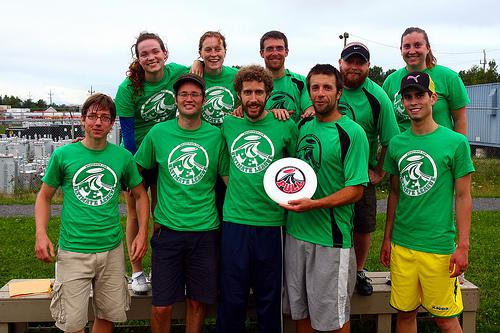Question: what is the main color of the frisbee?
Choices:
A. Red.
B. Blue.
C. Green.
D. White.
Answer with the letter. Answer: D Question: how many people are wearing hats?
Choices:
A. Two.
B. One.
C. Three.
D. Four.
Answer with the letter. Answer: C Question: who is this a picture of?
Choices:
A. Sports team.
B. Friends.
C. Frisbee team.
D. Soccer team.
Answer with the letter. Answer: C Question: what color are the shirts?
Choices:
A. Red.
B. Green.
C. Blue.
D. Pink.
Answer with the letter. Answer: B 